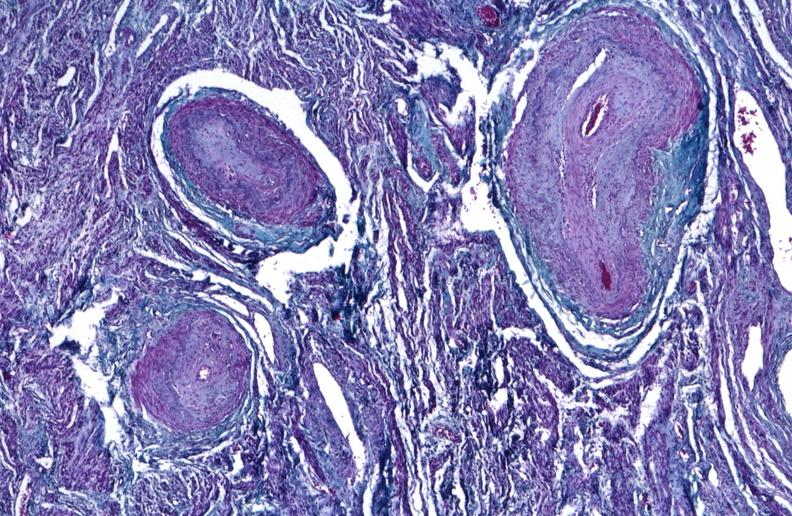what stain?
Answer the question using a single word or phrase. Trichrome 